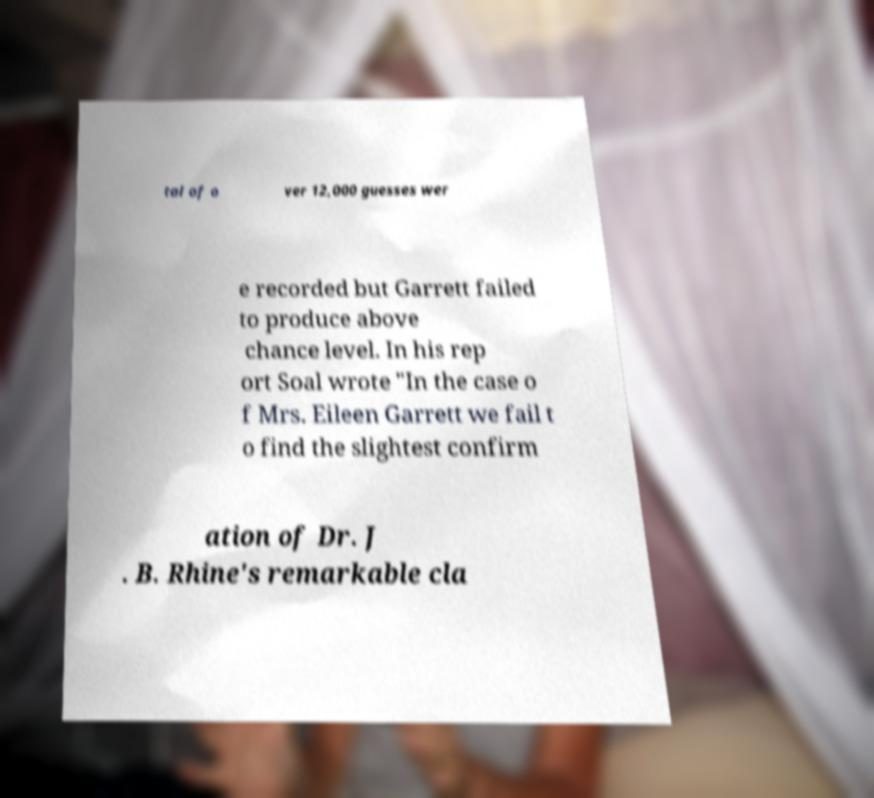Could you assist in decoding the text presented in this image and type it out clearly? tal of o ver 12,000 guesses wer e recorded but Garrett failed to produce above chance level. In his rep ort Soal wrote "In the case o f Mrs. Eileen Garrett we fail t o find the slightest confirm ation of Dr. J . B. Rhine's remarkable cla 